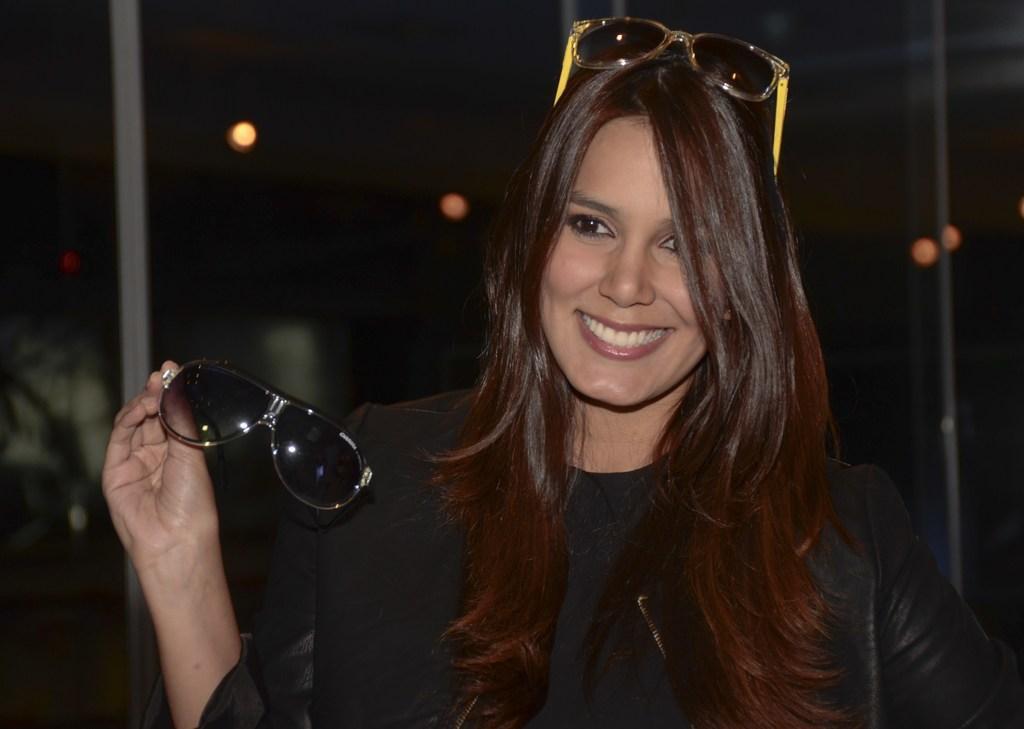Could you give a brief overview of what you see in this image? In the center of the image, we can see a lady wearing glasses, smiling and holding glasses. In the background, there are lights and we can see poles. 